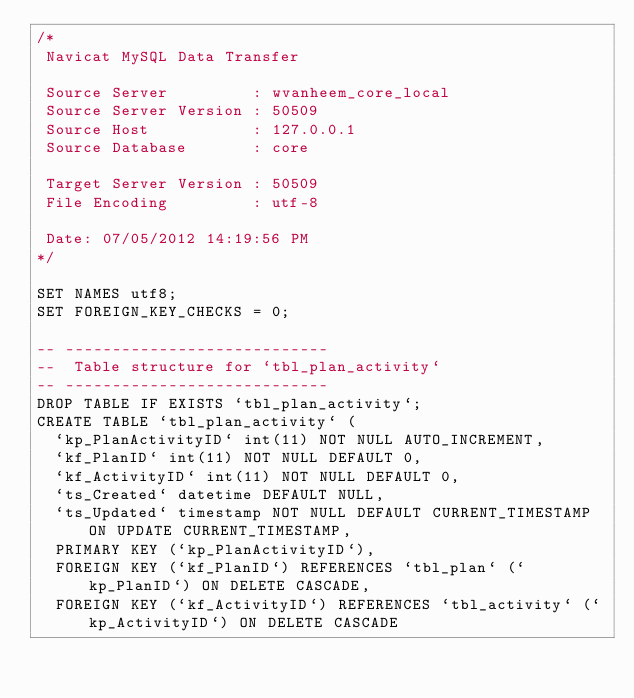<code> <loc_0><loc_0><loc_500><loc_500><_SQL_>/*
 Navicat MySQL Data Transfer

 Source Server         : wvanheem_core_local
 Source Server Version : 50509
 Source Host           : 127.0.0.1
 Source Database       : core

 Target Server Version : 50509
 File Encoding         : utf-8

 Date: 07/05/2012 14:19:56 PM
*/

SET NAMES utf8;
SET FOREIGN_KEY_CHECKS = 0;

-- ----------------------------
--  Table structure for `tbl_plan_activity`
-- ----------------------------
DROP TABLE IF EXISTS `tbl_plan_activity`;
CREATE TABLE `tbl_plan_activity` (
  `kp_PlanActivityID` int(11) NOT NULL AUTO_INCREMENT,
  `kf_PlanID` int(11) NOT NULL DEFAULT 0,
  `kf_ActivityID` int(11) NOT NULL DEFAULT 0,
  `ts_Created` datetime DEFAULT NULL,
  `ts_Updated` timestamp NOT NULL DEFAULT CURRENT_TIMESTAMP ON UPDATE CURRENT_TIMESTAMP,
  PRIMARY KEY (`kp_PlanActivityID`),
  FOREIGN KEY (`kf_PlanID`) REFERENCES `tbl_plan` (`kp_PlanID`) ON DELETE CASCADE,
  FOREIGN KEY (`kf_ActivityID`) REFERENCES `tbl_activity` (`kp_ActivityID`) ON DELETE CASCADE</code> 